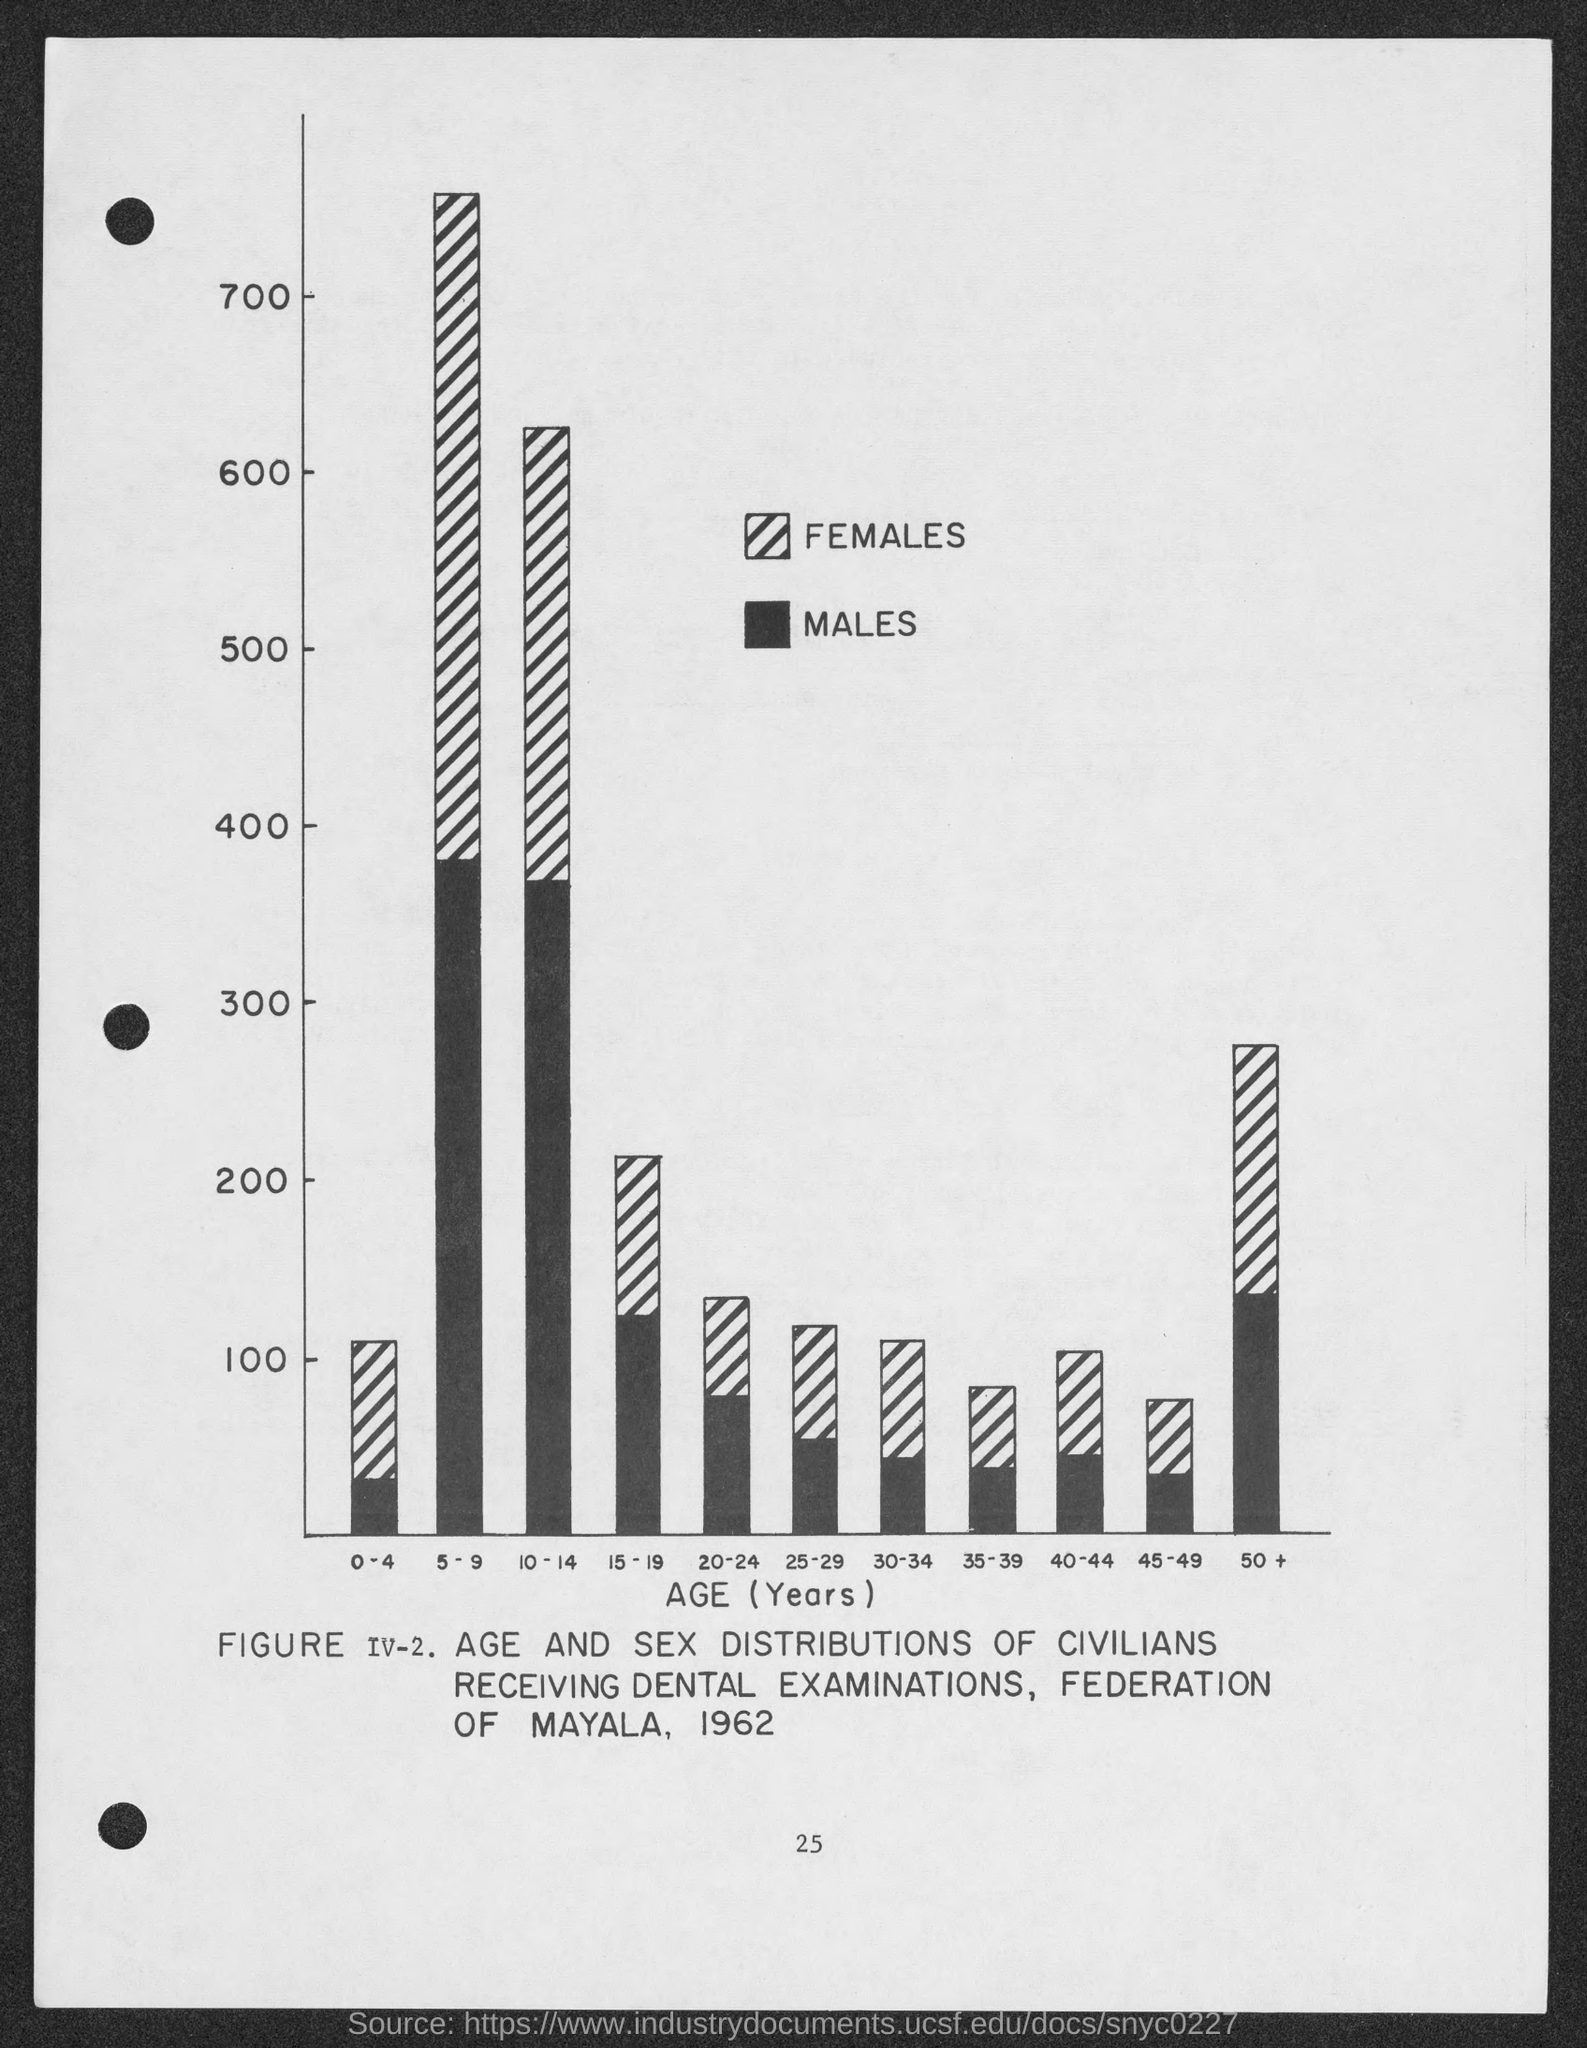What is the number at bottom of the page?
Keep it short and to the point. 25. What is given on the x-axis of the figure ?
Make the answer very short. Age (years). 